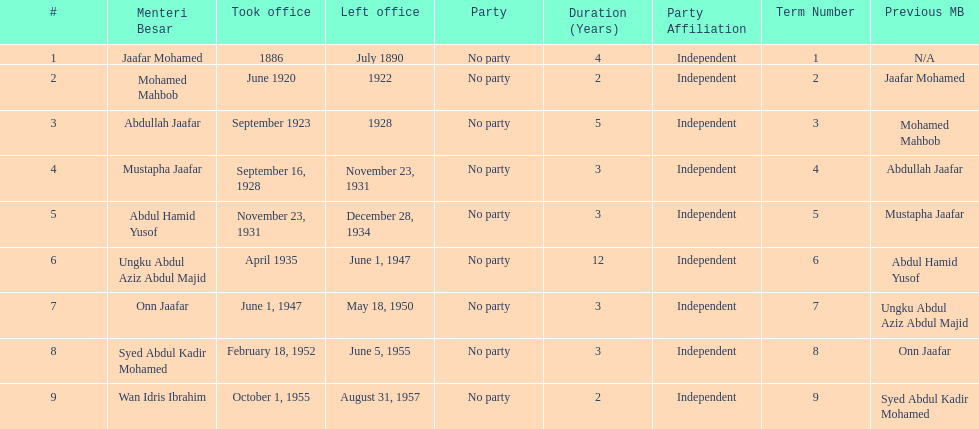Who was in office after mustapha jaafar Abdul Hamid Yusof. 